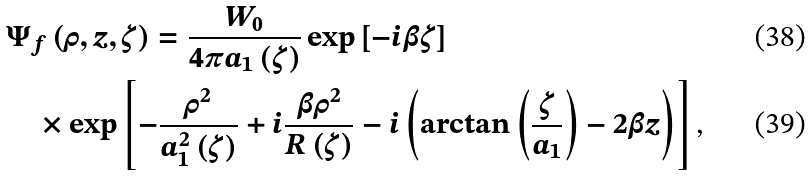<formula> <loc_0><loc_0><loc_500><loc_500>& \Psi _ { f } \left ( \rho , z , \zeta \right ) = \frac { W _ { 0 } } { 4 \pi a _ { 1 } \left ( \zeta \right ) } \exp \left [ - i \beta \zeta \right ] \\ & \quad \times \exp \left [ - \frac { \rho ^ { 2 } } { a _ { 1 } ^ { 2 } \left ( \zeta \right ) } + i \frac { \beta \rho ^ { 2 } } { R \left ( \zeta \right ) } - i \left ( \arctan \left ( \frac { \zeta } { a _ { 1 } } \right ) - 2 \beta z \right ) \right ] \text {,}</formula> 